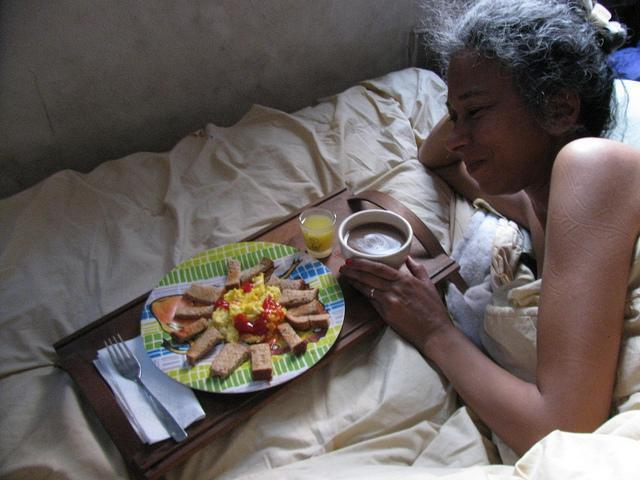How many bowls are in the picture?
Give a very brief answer. 1. 